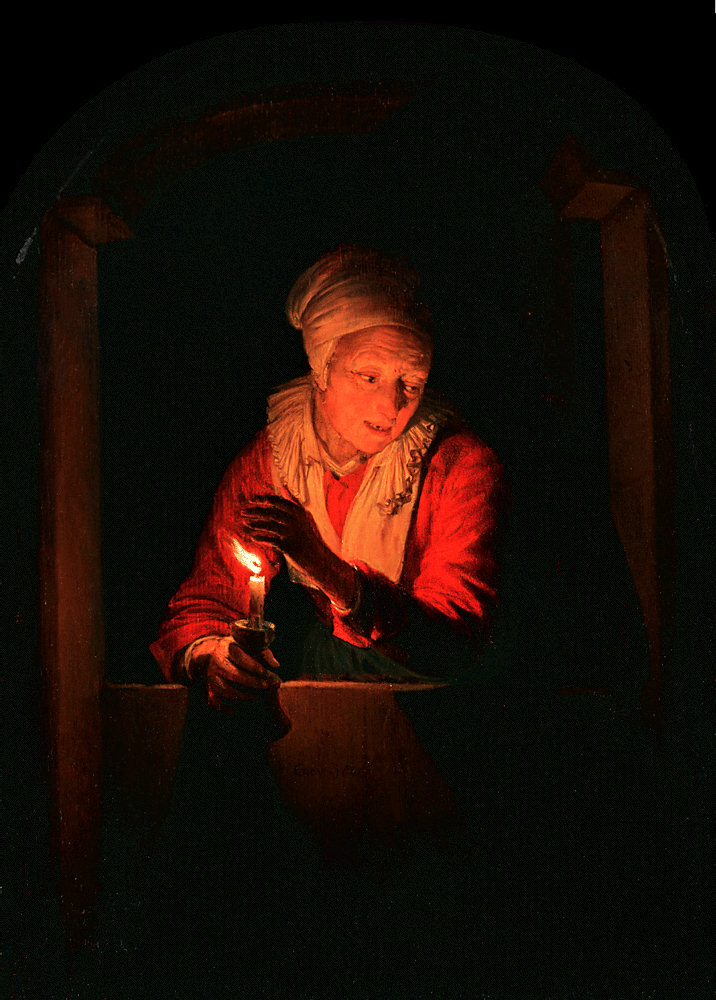What's happening in the scene? The painting portrays an elderly woman, bathed in the warm, soft glow from a candle she gently holds, reflecting a sense of peace and introspection. Dressed in a white headscarf and a vivid red shawl, her expression is one of calm and contemplation, suggesting a moment of solitude or perhaps prayer. The scene is framed within an arched window, the sole source of illumination against the enveloping darkness, which accentuates the intimacy of the candlelit moment. The juxtaposition of warm and dark tones along with the woman's serene expression evokes a poignant atmosphere, possibly hinting at themes of aging, wisdom, or resilience in the face of darkness. 